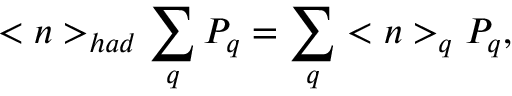<formula> <loc_0><loc_0><loc_500><loc_500>< n > _ { h a d } \sum _ { q } P _ { q } = \sum _ { q } < n > _ { q } P _ { q } ,</formula> 